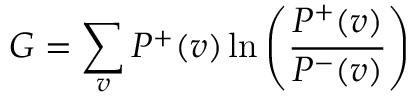Convert formula to latex. <formula><loc_0><loc_0><loc_500><loc_500>G = \sum _ { v } { P ^ { + } ( v ) \ln \left ( { \frac { P ^ { + } ( v ) } { P ^ { - } ( v ) } } \right ) }</formula> 